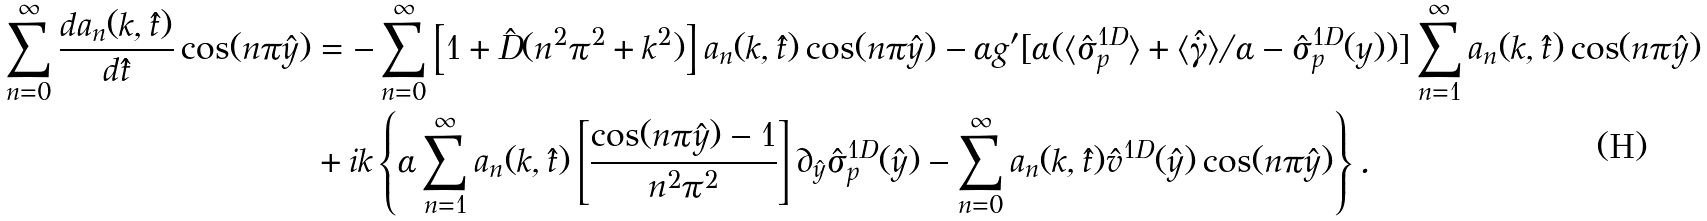<formula> <loc_0><loc_0><loc_500><loc_500>\sum _ { n = 0 } ^ { \infty } \frac { d a _ { n } ( k , \hat { t } ) } { d \hat { t } } \cos ( n \pi \hat { y } ) & = - \sum _ { n = 0 } ^ { \infty } \left [ 1 + \hat { D } ( n ^ { 2 } \pi ^ { 2 } + k ^ { 2 } ) \right ] a _ { n } ( k , \hat { t } ) \cos ( n \pi \hat { y } ) - \alpha g ^ { \prime } [ \alpha ( \langle \hat { \sigma } _ { p } ^ { 1 D } \rangle + \langle { \hat { \dot { \gamma } } } \rangle / \alpha - \hat { \sigma } _ { p } ^ { 1 D } ( y ) ) ] \sum _ { n = 1 } ^ { \infty } a _ { n } ( k , \hat { t } ) \cos ( n \pi \hat { y } ) \\ & + i k \left \{ \alpha \sum _ { n = 1 } ^ { \infty } a _ { n } ( k , \hat { t } ) \left [ \frac { \cos ( n \pi \hat { y } ) - 1 } { n ^ { 2 } \pi ^ { 2 } } \right ] \partial _ { \hat { y } } \hat { \sigma } _ { p } ^ { 1 D } ( \hat { y } ) - \sum _ { n = 0 } ^ { \infty } a _ { n } ( k , \hat { t } ) \hat { v } ^ { 1 D } ( \hat { y } ) \cos ( n \pi \hat { y } ) \right \} .</formula> 